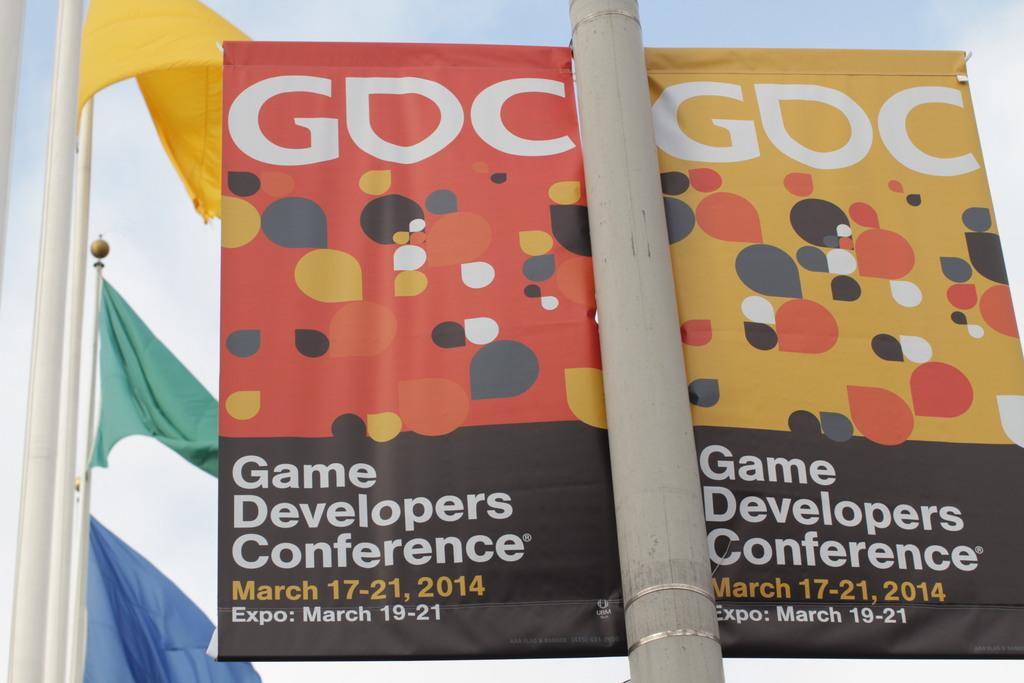<image>
Give a short and clear explanation of the subsequent image. A promotional banner states that a Game Developers Conference takes place from March 17th to the 21st. 